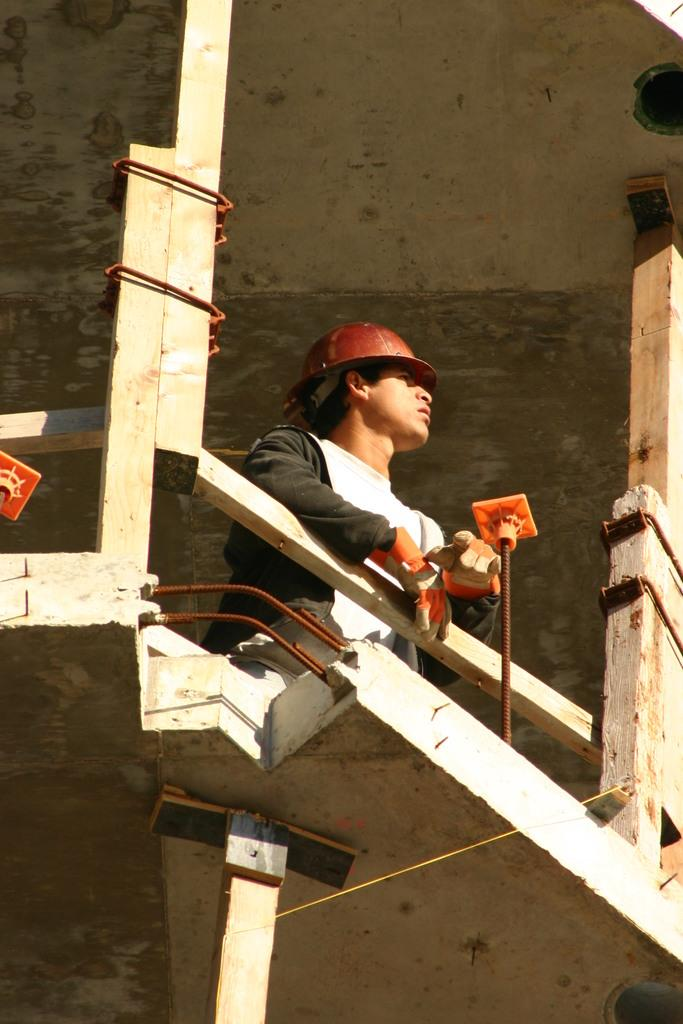What is the main subject of the image? There is a person standing in the image. What type of location does the image appear to depict? The image appears to depict a construction site. What type of material can be seen in the image? There are wooden poles visible in the image. What type of advice can be heard being given in the image? There is no audio or dialogue present in the image, so it is not possible to determine what advice might be given. 